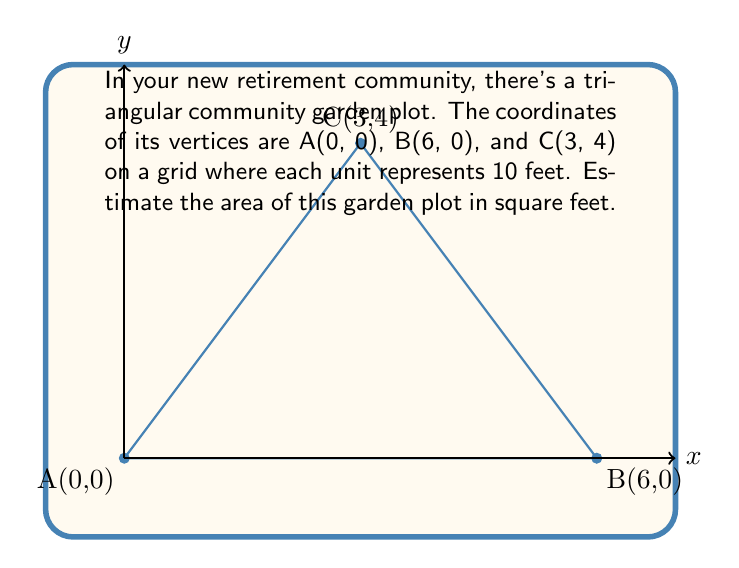Can you answer this question? Let's approach this step-by-step:

1) To find the area of a triangle given the coordinates of its vertices, we can use the formula:

   $$\text{Area} = \frac{1}{2}|x_1(y_2 - y_3) + x_2(y_3 - y_1) + x_3(y_1 - y_2)|$$

   where $(x_1, y_1)$, $(x_2, y_2)$, and $(x_3, y_3)$ are the coordinates of the three vertices.

2) We have:
   A(0, 0), B(6, 0), and C(3, 4)
   
   So, $x_1 = 0$, $y_1 = 0$, $x_2 = 6$, $y_2 = 0$, $x_3 = 3$, $y_3 = 4$

3) Let's substitute these into our formula:

   $$\text{Area} = \frac{1}{2}|0(0 - 4) + 6(4 - 0) + 3(0 - 0)|$$

4) Simplify:
   $$\text{Area} = \frac{1}{2}|0 + 24 + 0| = \frac{1}{2}(24) = 12$$

5) This gives us the area in square units. Remember that each unit represents 10 feet, so we need to multiply our result by $10^2 = 100$:

   $$12 * 100 = 1200$$

Therefore, the estimated area of the garden plot is 1200 square feet.
Answer: 1200 square feet 